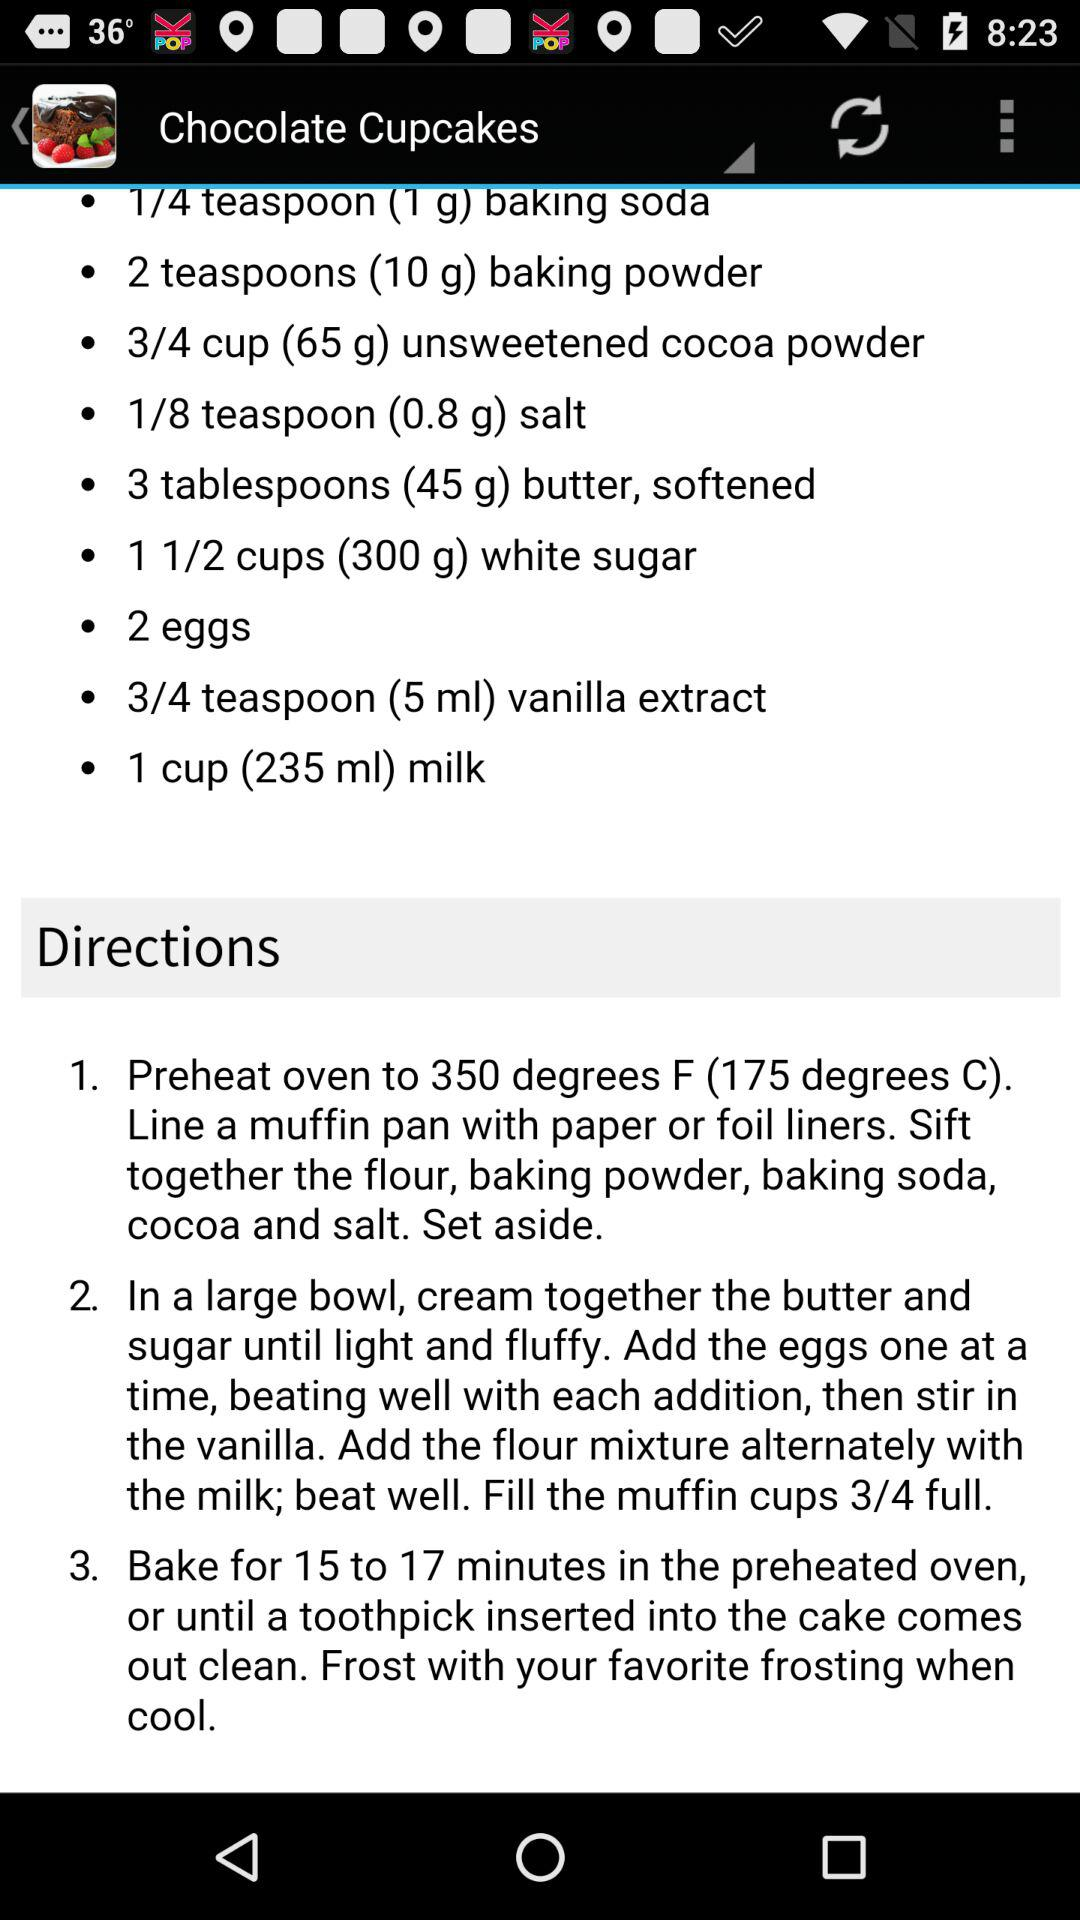What is the recommended quantity of baking powder for the "Chocolate Cupcakes"? The recommended quantity of baking powder for the "Chocolate Cupcakes" is 2 teaspoons (10 g). 